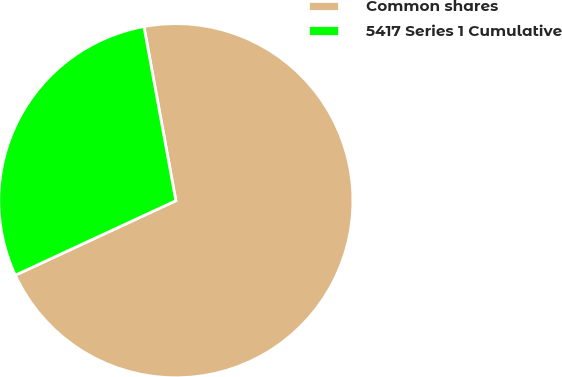<chart> <loc_0><loc_0><loc_500><loc_500><pie_chart><fcel>Common shares<fcel>5417 Series 1 Cumulative<nl><fcel>70.97%<fcel>29.03%<nl></chart> 